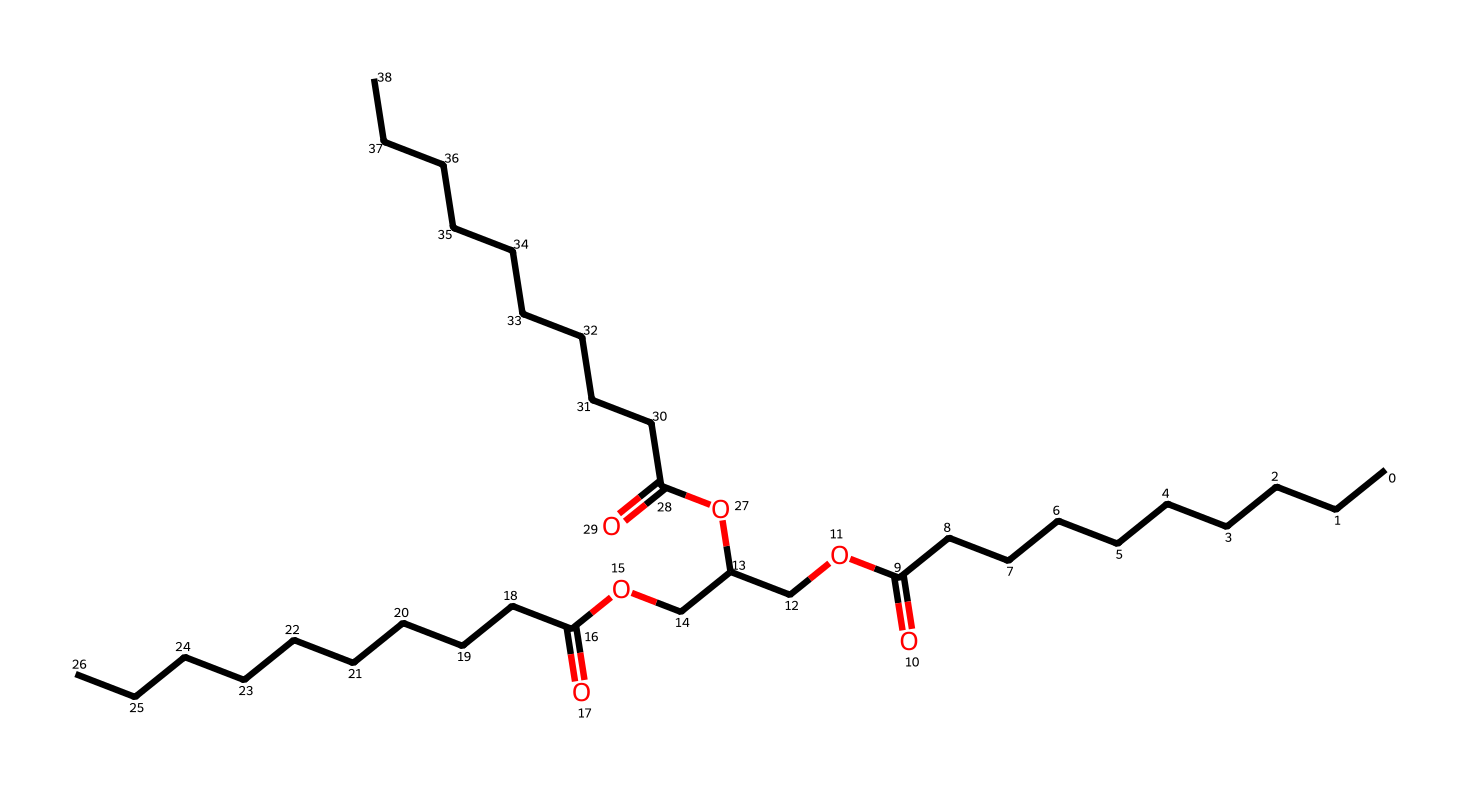What is the molecular formula of this biolubricant? To determine the molecular formula, we can analyze the SMILES representation. Each atom is counted based on its representation: 'C' for carbon, 'O' for oxygen, and the absence of specific atoms indicates hydrogen atoms are implied. Counting shows that there are 36 carbon (C) atoms, 6 oxygen (O) atoms, leading to the formula C36H70O6.
Answer: C36H70O6 How many ester functional groups are present in this compound? By examining the structure indicated in the SMILES representation, we can identify ester functional groups, which are characterized by the COO structure. Scanning through the molecule shows there are three instances of ester linkages, confirming the presence of three ester functional groups.
Answer: 3 Which carbon chain is the longest in this biolubricant? In the SMILES representation, the longest continuous carbon chain can be found by scanning for the longest segment represented by 'C' without disruption. Counting these segments, we find that there are 10 carbons in the longest straight chain as indicated before the first COO.
Answer: 10 What renewable resource is most likely used for this biolubricant? The structure suggests that it is derived from vegetable oils, which are common renewable resources for biolubricants. The presence of long carbon chains indicates a fatty acid composition typical of vegetable oils, pointing to this as the likely renewable source.
Answer: vegetable oils Is this biolubricant likely to be biodegradable? Given that the compound is constructed from natural fatty acids and glycerol-like components influenced by renewable feedstocks, which are known for being biodegradable, it is reasonable to conclude that this lubricating compound is biodegradable due to the lack of synthetic structures.
Answer: yes What type of lubrication property do biolubricants typically enhance? Biolubricants are known for enhancing characteristics such as biodegradability, eco-friendliness, and low toxicity. This specific structure, rich in fatty acid esters, typically enhances the lubrication properties of reducing friction in mechanical systems.
Answer: reduce friction 